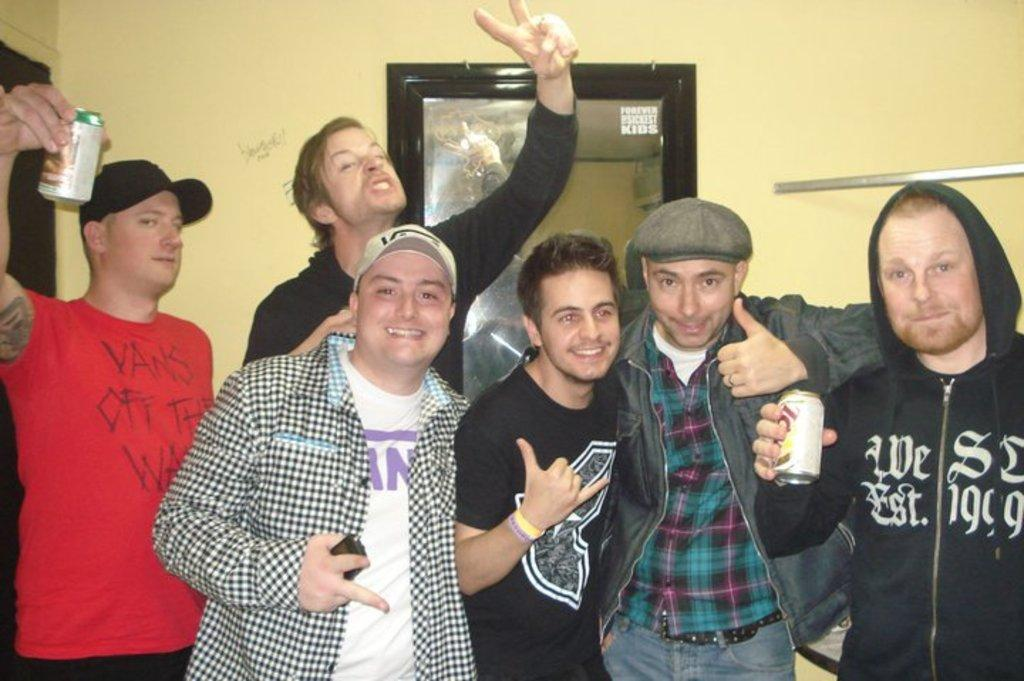<image>
Provide a brief description of the given image. six men taking a picture together, with one of them wearing a vans shirt 